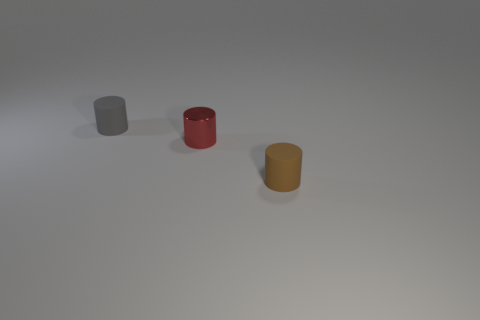Add 2 yellow metallic spheres. How many objects exist? 5 Subtract 0 cyan cylinders. How many objects are left? 3 Subtract all yellow spheres. Subtract all metal cylinders. How many objects are left? 2 Add 2 small metallic objects. How many small metallic objects are left? 3 Add 2 tiny brown things. How many tiny brown things exist? 3 